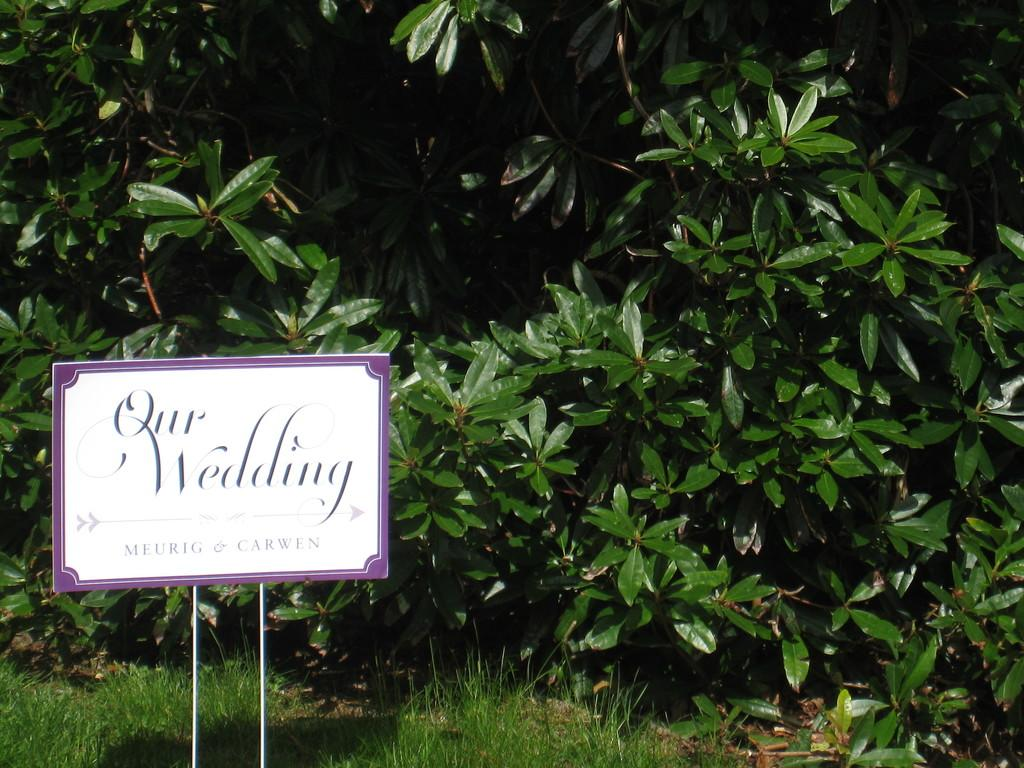What object in the image is used for displaying names? There is a name board in the image. What type of natural environment is visible in the image? There is grass visible in the image. What can be seen in the background of the image? There are trees in the background of the image. What type of birthday celebration is taking place in the image? There is no indication of a birthday celebration in the image. What type of trains can be seen passing by in the image? There are no trains present in the image. What type of shirt is the person in the image wearing? There is no person visible in the image, so it is not possible to determine what type of shirt they might be wearing. 